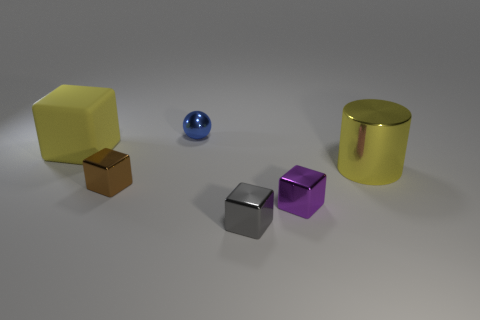There is a large thing that is the same color as the rubber cube; what material is it?
Your answer should be very brief. Metal. How many balls are either small blue metallic objects or matte things?
Provide a succinct answer. 1. There is a rubber object that is the same size as the metal cylinder; what color is it?
Make the answer very short. Yellow. Is there any other thing that has the same shape as the rubber object?
Make the answer very short. Yes. The other matte object that is the same shape as the brown object is what color?
Ensure brevity in your answer.  Yellow. What number of objects are either metallic blocks or tiny metal things that are in front of the large yellow matte object?
Provide a succinct answer. 3. Are there fewer tiny gray shiny blocks in front of the gray shiny block than blue metallic balls?
Offer a very short reply. Yes. How big is the object that is behind the cube that is behind the big yellow thing that is right of the small blue shiny ball?
Make the answer very short. Small. What color is the shiny block that is both to the left of the purple block and to the right of the brown block?
Your answer should be compact. Gray. What number of purple matte spheres are there?
Your response must be concise. 0. 